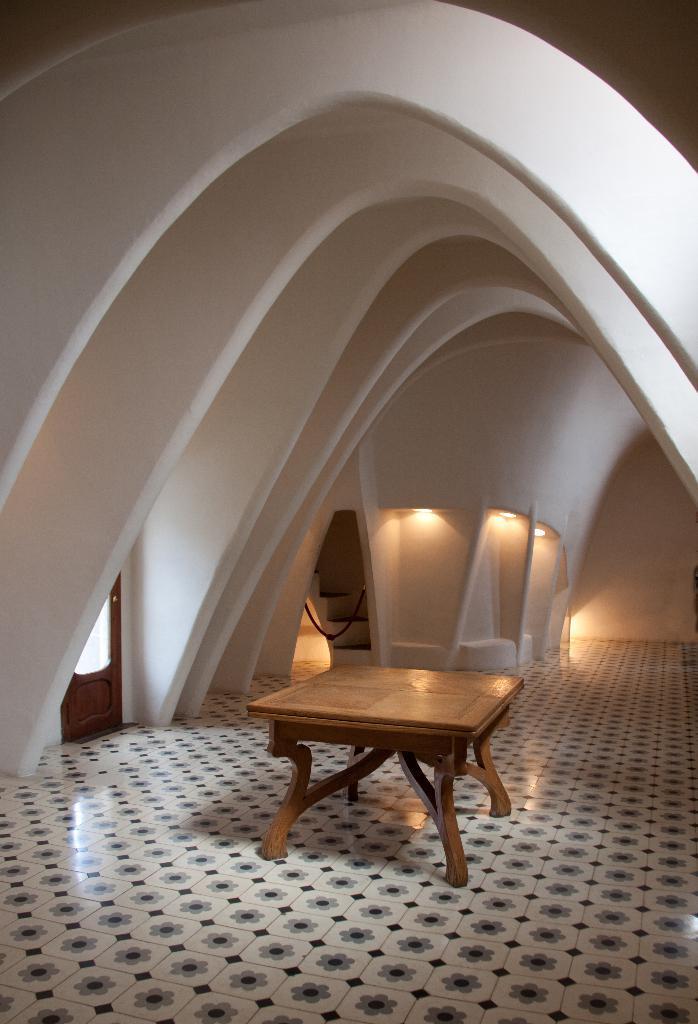Describe this image in one or two sentences. In this picture there is a table and there is a architecture wall above it and there is a door in the left corner and there are some other objects in the background. 